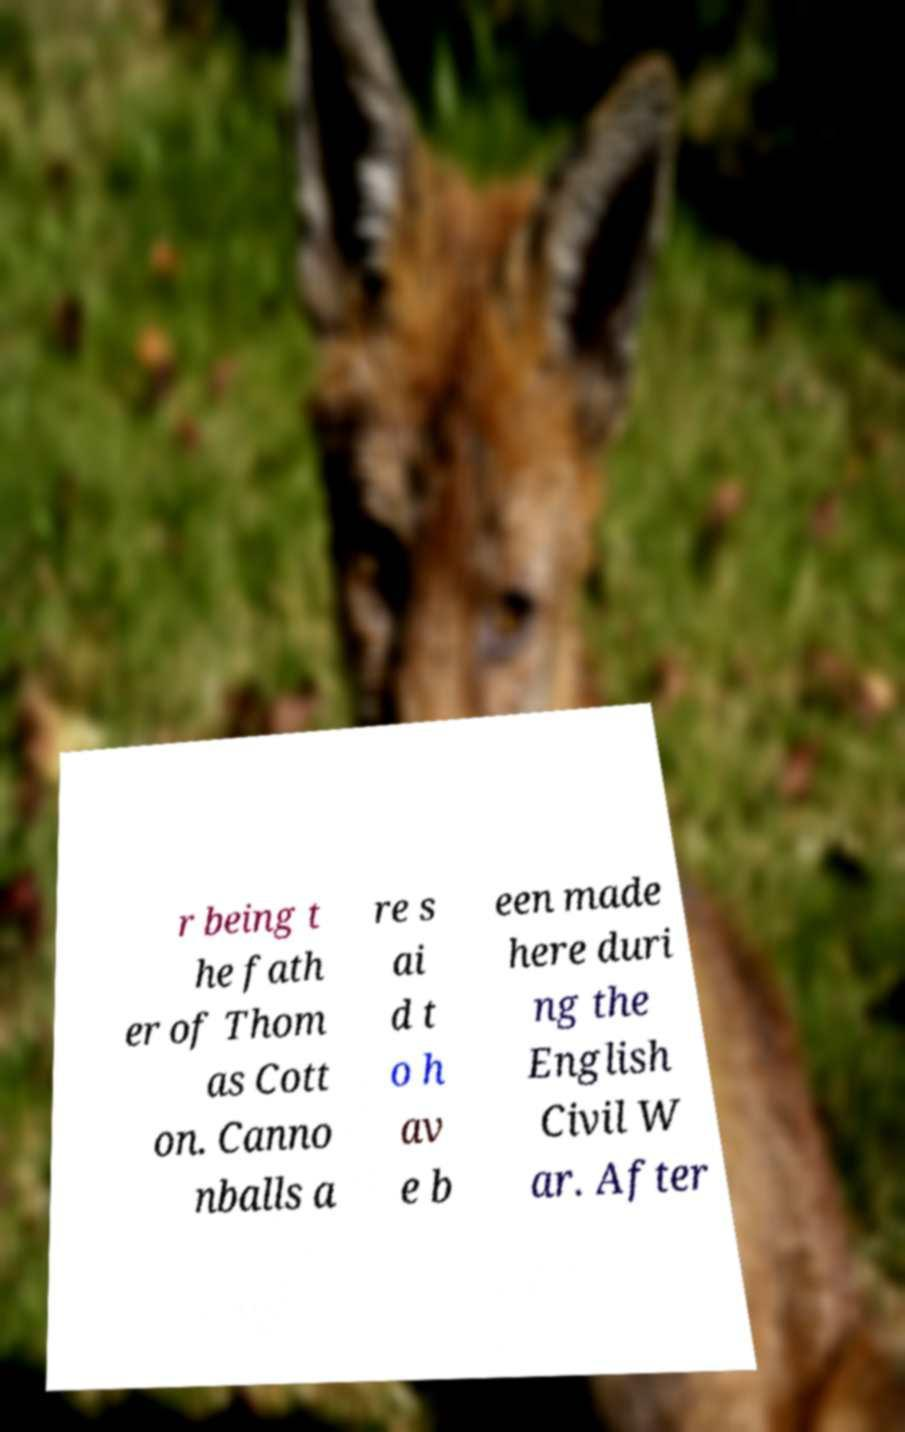Please identify and transcribe the text found in this image. r being t he fath er of Thom as Cott on. Canno nballs a re s ai d t o h av e b een made here duri ng the English Civil W ar. After 